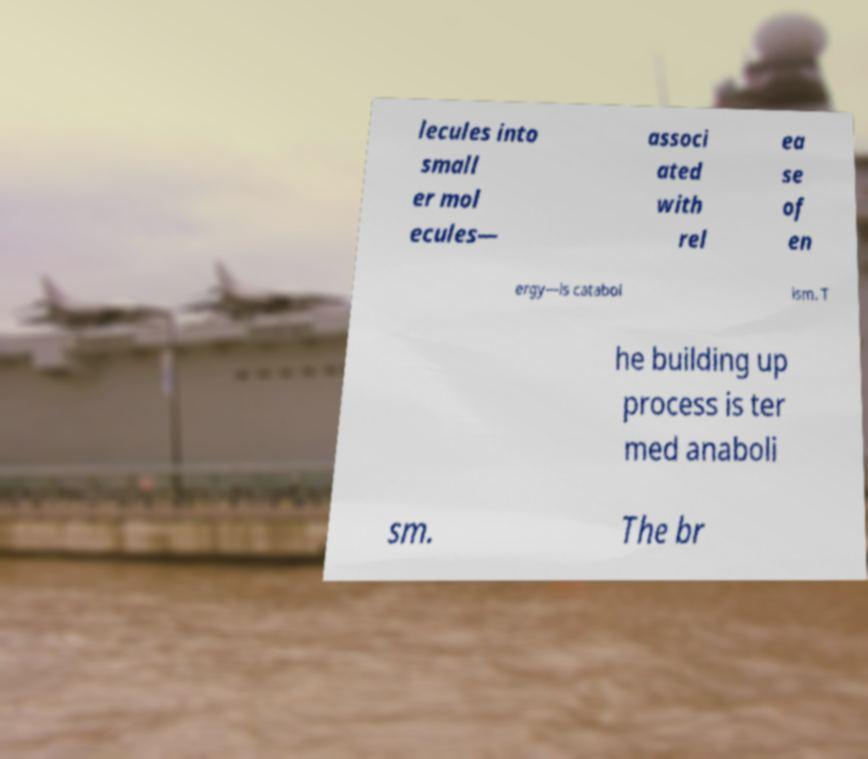Could you extract and type out the text from this image? lecules into small er mol ecules— associ ated with rel ea se of en ergy—is catabol ism. T he building up process is ter med anaboli sm. The br 